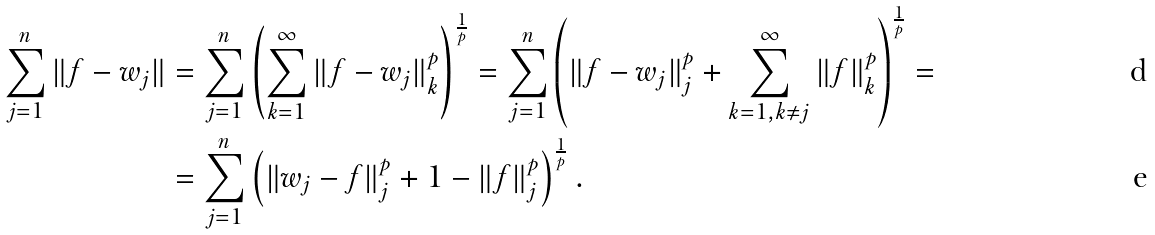<formula> <loc_0><loc_0><loc_500><loc_500>\sum _ { j = 1 } ^ { n } \| f - w _ { j } \| & = \sum _ { j = 1 } ^ { n } \left ( \sum _ { k = 1 } ^ { \infty } \| f - w _ { j } \| ^ { p } _ { k } \right ) ^ { \frac { 1 } { p } } = \sum _ { j = 1 } ^ { n } \left ( \| f - w _ { j } \| ^ { p } _ { j } + \sum _ { k = 1 , k \ne j } ^ { \infty } \| f \| ^ { p } _ { k } \right ) ^ { \frac { 1 } { p } } = \\ & = \sum _ { j = 1 } ^ { n } \left ( \| w _ { j } - f \| ^ { p } _ { j } + 1 - \| f \| ^ { p } _ { j } \right ) ^ { \frac { 1 } { p } } .</formula> 